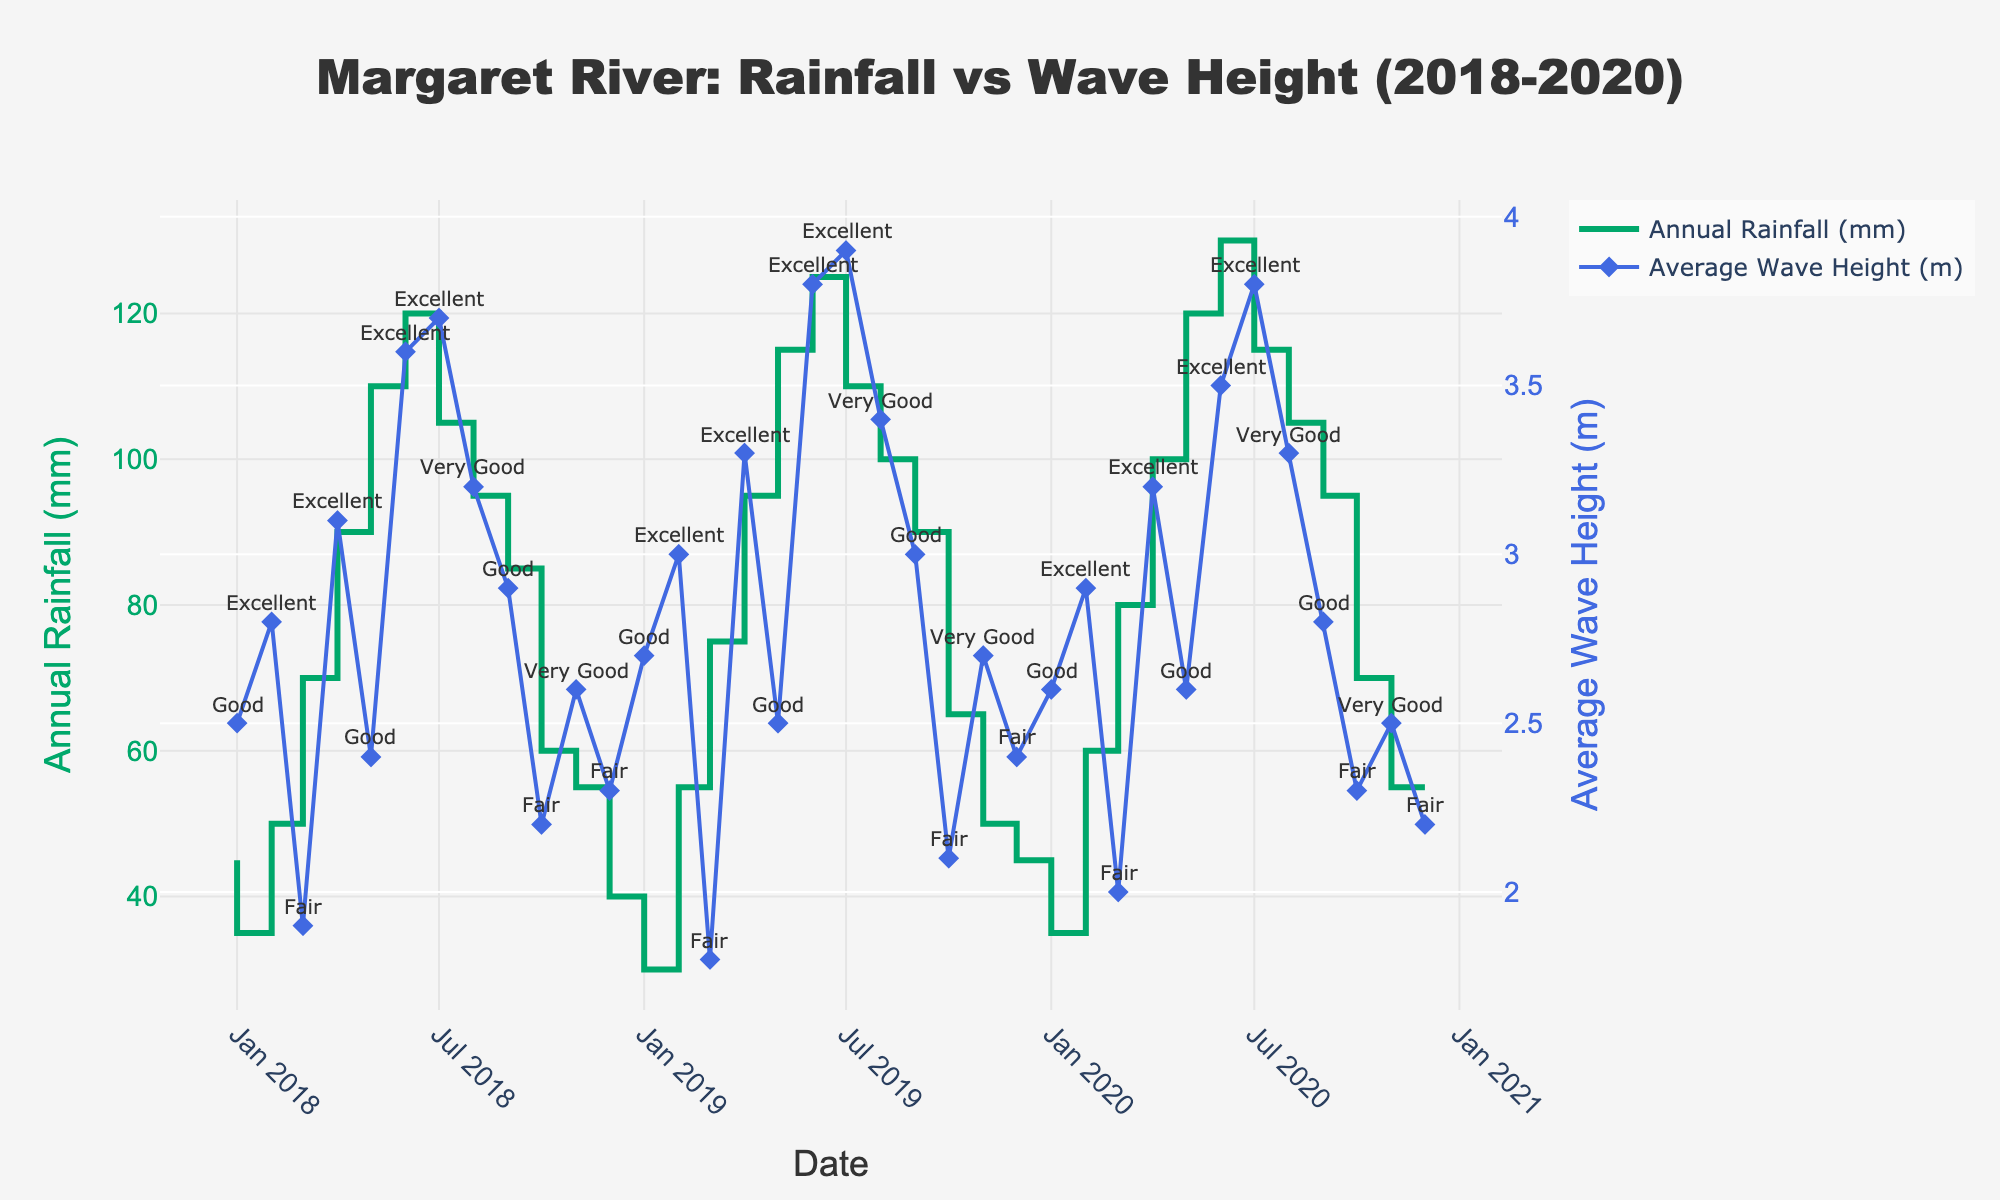What is the title of the chart? The chart title is displayed prominently at the top of the figure.
Answer: Margaret River: Rainfall vs Wave Height (2018-2020) What color represents the Annual Rainfall data in the plot? The Annual Rainfall data is represented by lines with a specific color.
Answer: Green Which month and year had the highest average wave height? Find the peak points on the wave height line and refer to the x-axis for the corresponding month and year.
Answer: July 2019 How many data points are shown for each year? Count the number of intervals on the x-axis corresponding to each year.
Answer: 12 In which months were the surf conditions rated as "Excellent"? Look for annotations marked as "Excellent" next to the wave heights.
Answer: February 2018, April 2018, June 2018, July 2018, June 2019, July 2019, February 2019, June 2020, July 2020, April 2020 Did any month between 2018 and 2020 feature both high rainfall and excellent surf conditions? Identify months with high rainfalls (peaks in green line) and check their surf conditions.
Answer: April 2018, June 2018, July 2018, April 2019, June 2019, July 2019, June 2020, July 2020 Compare the annual rainfall in June across all years shown. Which year had the most rainfall in June? Locate the June data points for each year on the green line and compare their heights.
Answer: 2020 What is the average wave height in 2019? Find the average of the wave heights for each month in 2019.
Answer: (2.7+3.0+1.8+3.3+2.5+3.8+3.9+3.4+3.0+2.1+2.7+2.4)/12 = 3.025 meters What is the difference in rainfall between July 2018 and July 2019? Subtract the value of rainfall in July 2018 from that in July 2019.
Answer: 5 mm (125 - 120) What surf condition annotation appears most frequently in the figure? Identify which surf condition annotations are repeated the most.
Answer: Excellent 